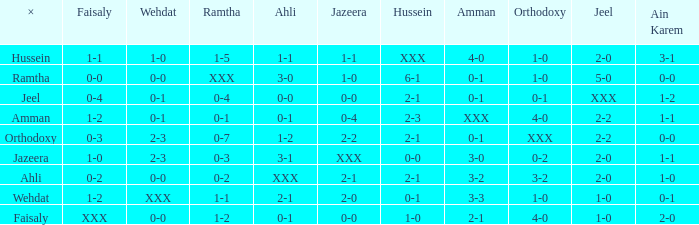What is faisaly when wehdat is xxx? 1-2. 